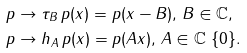Convert formula to latex. <formula><loc_0><loc_0><loc_500><loc_500>& p \rightarrow \tau _ { B } \, p ( x ) = p ( x - B ) , \, B \in \mathbb { C } , \\ & p \rightarrow h _ { A } \, p ( x ) = p ( A x ) , \, A \in \mathbb { C } \ \{ 0 \} .</formula> 